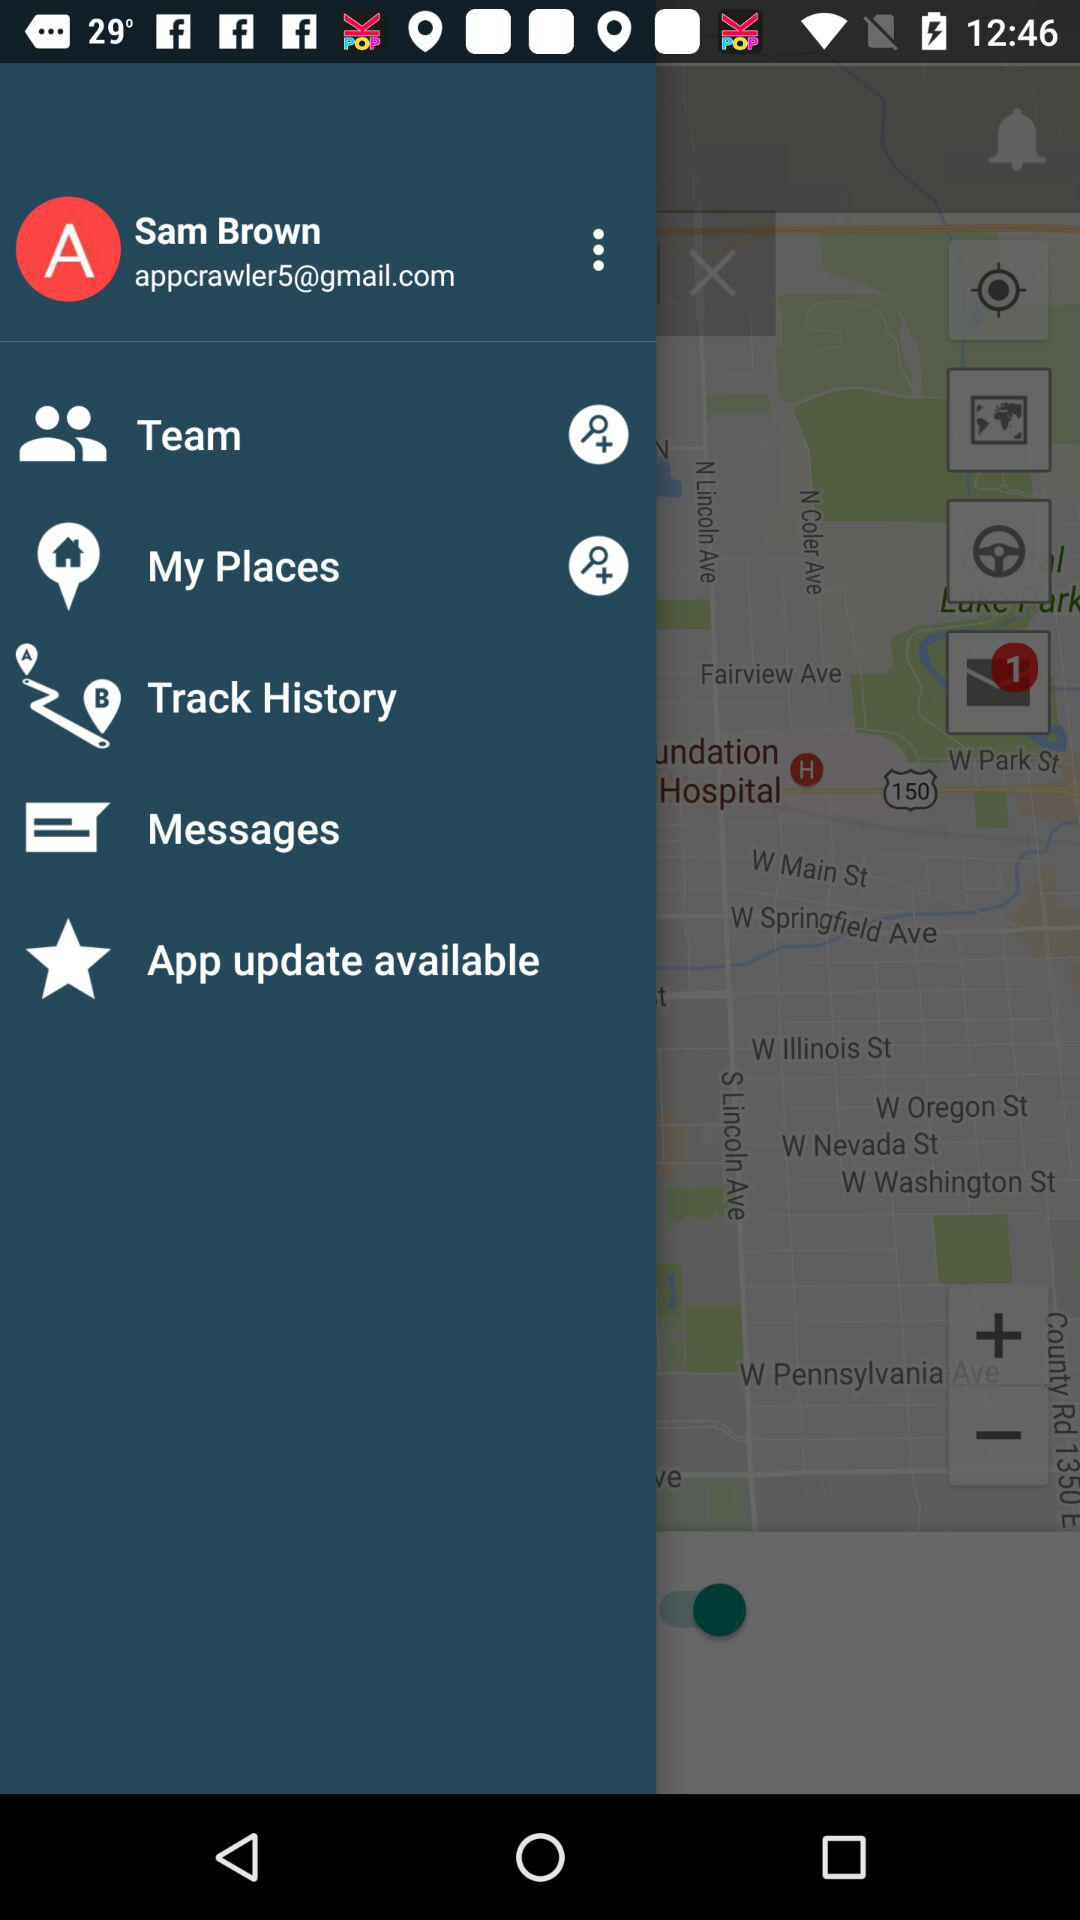What is the user name? The user name is "Sam Brown". 